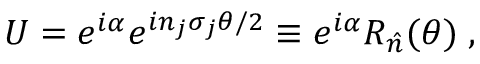<formula> <loc_0><loc_0><loc_500><loc_500>U = e ^ { i \alpha } e ^ { i n _ { j } \sigma _ { j } \theta / 2 } \equiv e ^ { i \alpha } R _ { \hat { n } } ( \theta ) \, ,</formula> 